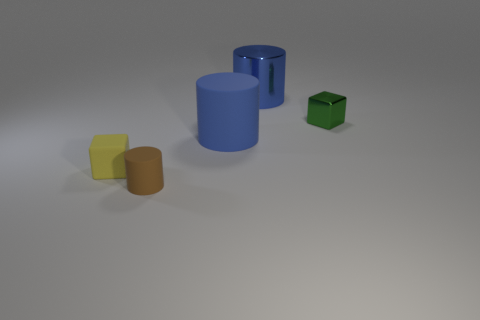There is a cylinder that is the same color as the large matte thing; what is it made of?
Ensure brevity in your answer.  Metal. Do the big cylinder in front of the green thing and the big thing to the right of the big blue rubber object have the same color?
Offer a very short reply. Yes. Are there any cylinders that have the same color as the small metallic object?
Ensure brevity in your answer.  No. The other cylinder that is the same size as the blue metal cylinder is what color?
Your answer should be very brief. Blue. What number of big things are either blocks or green things?
Give a very brief answer. 0. Are there the same number of brown rubber things on the right side of the brown rubber thing and blue things that are left of the big rubber object?
Ensure brevity in your answer.  Yes. What number of green cylinders have the same size as the blue matte cylinder?
Your response must be concise. 0. What number of green things are tiny matte cylinders or tiny rubber blocks?
Your answer should be very brief. 0. Is the number of small yellow matte blocks to the right of the tiny yellow rubber object the same as the number of green shiny blocks?
Your response must be concise. No. There is a blue cylinder on the left side of the big metallic cylinder; what size is it?
Provide a succinct answer. Large. 